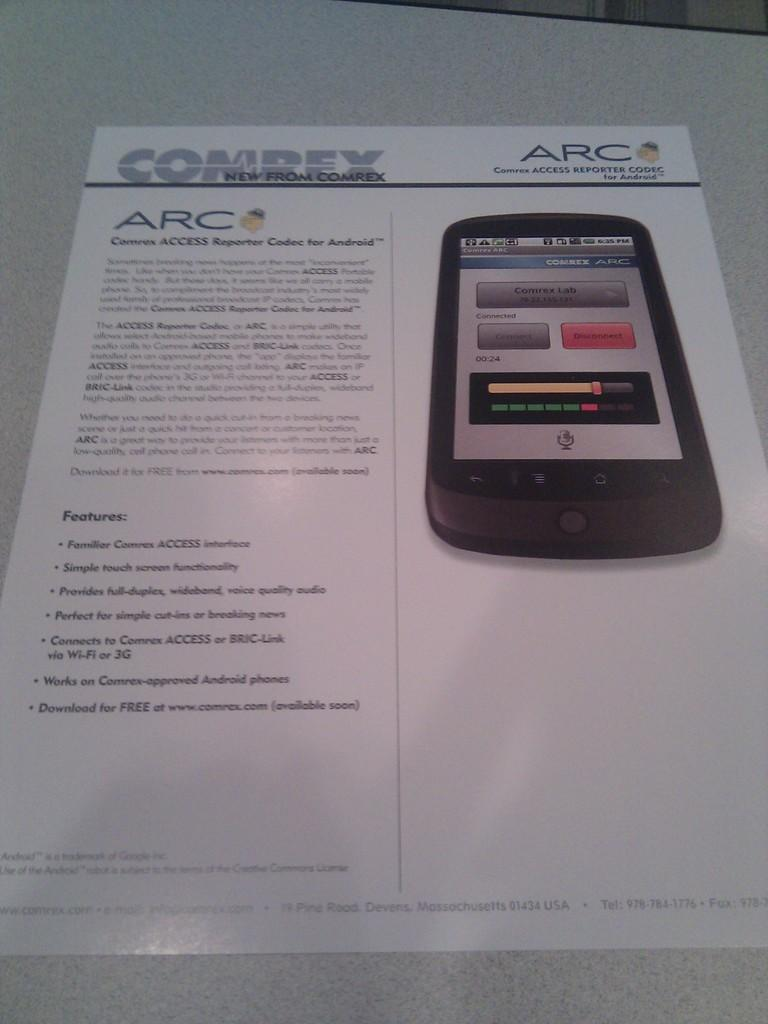<image>
Share a concise interpretation of the image provided. a paper that has ARC written at the top 